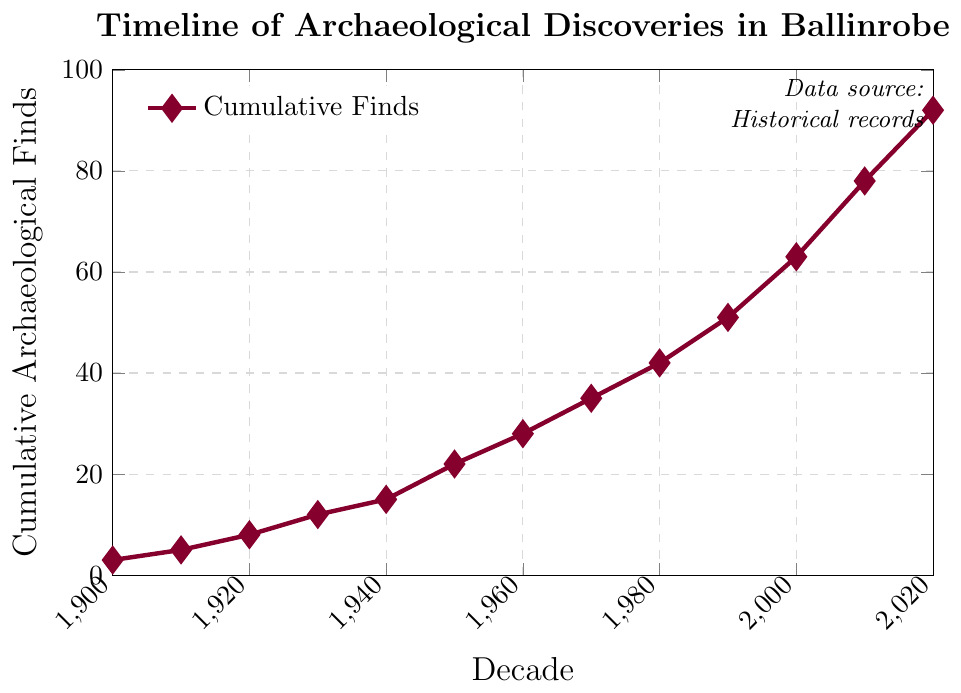How many cumulative archaeological finds were there in the year 1960? To find the answer, locate the data point at 1960 on the horizontal axis and find its corresponding value on the vertical axis. The graph shows 28 finds in 1960.
Answer: 28 How much did the cumulative finds increase from 1940 to 1950? Locate the values at 1940 and 1950 on the vertical axis: they are 15 and 22, respectively. Subtract the finds in 1940 from the finds in 1950: 22 - 15 = 7.
Answer: 7 Which decade saw the highest increase in cumulative finds? To determine this, calculate the increase for each decade and compare them. For example, from 2000 to 2010, the increase is 78 - 63 = 15, and from 2010 to 2020, the increase is 92 - 78 = 14. The decade with the highest increase is from 2000 to 2010, with an increase of 15.
Answer: 2000 to 2010 What is the trend of cumulative archaeological finds from 1900 to 2020? Examine the general direction of the line from 1900 to 2020. The line shows a consistent upward trend, indicating a steady increase in cumulative finds over time.
Answer: Increasing What is the approximate average increase in finds per decade from 1900 to 2020? First, find the cumulative increase over the entire period: 92 (2020) - 3 (1900) = 89. There are 12 decades from 1900 to 2020. Divide the total increase by the number of decades: 89 / 12 ≈ 7.42.
Answer: ≈ 7.42 By how much did the cumulative finds increase from 1980 to 2020? Calculate the difference in cumulative finds between 2020 and 1980: 92 - 42 = 50.
Answer: 50 What is the cumulative increase in archaeological finds between 1920 and 1970? Find the values at 1920 and 1970 on the vertical axis and calculate the difference: 35 - 8 = 27.
Answer: 27 What is the cumulative number of archaeological finds by the year 2000, and how does it compare to the number in 2010? Locate the values at 2000 and 2010: they are 63 and 78, respectively. The difference between 78 and 63 is 15.
Answer: 2000: 63; Difference: 15 